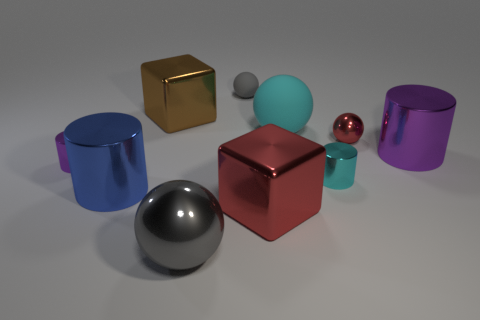Subtract all balls. How many objects are left? 6 Subtract 0 yellow blocks. How many objects are left? 10 Subtract all gray rubber things. Subtract all red balls. How many objects are left? 8 Add 5 gray spheres. How many gray spheres are left? 7 Add 7 large gray metal objects. How many large gray metal objects exist? 8 